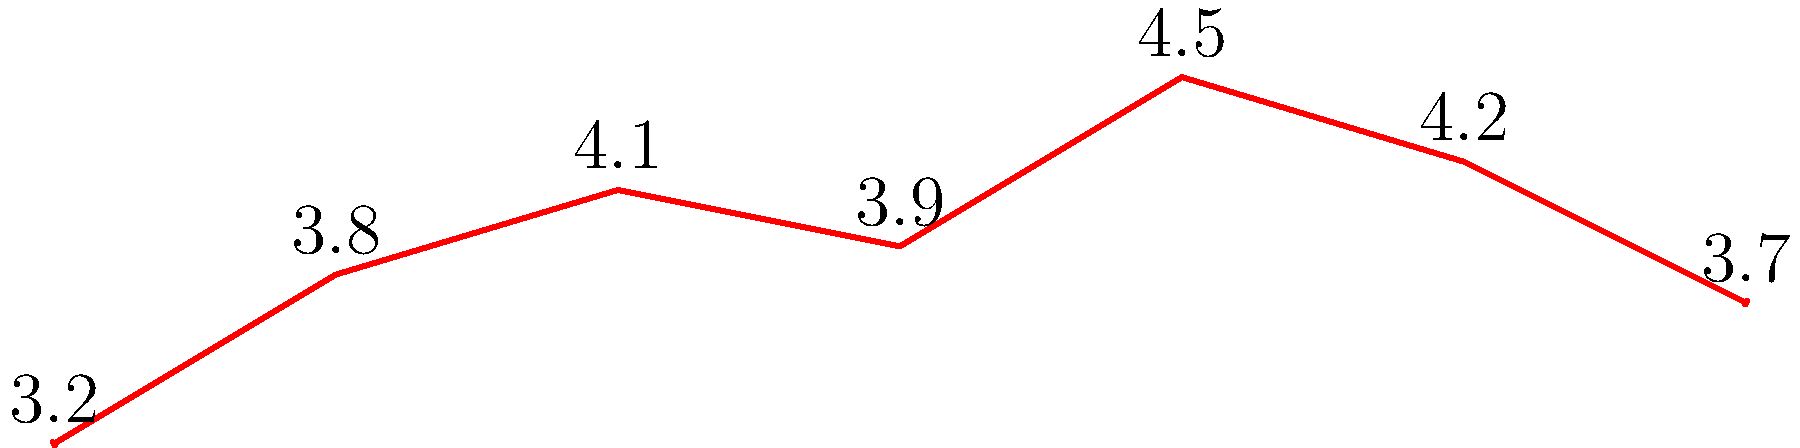Based on the timeline graph showing the viewership ratings of "Koffee with Karan" across its various seasons, which season had the highest viewership rating, and what was that rating? To answer this question, we need to examine the graph carefully:

1. The graph shows viewership ratings for 7 seasons of "Koffee with Karan".
2. Each bar represents a season, with the height of the bar indicating the viewership rating in millions.
3. We need to identify the tallest bar, which represents the highest rating.
4. Looking at the graph, we can see that Season 5 has the tallest bar.
5. The label above the bar for Season 5 shows the exact rating: 4.5 million viewers.

Therefore, Season 5 had the highest viewership rating at 4.5 million viewers.
Answer: Season 5, 4.5 million 